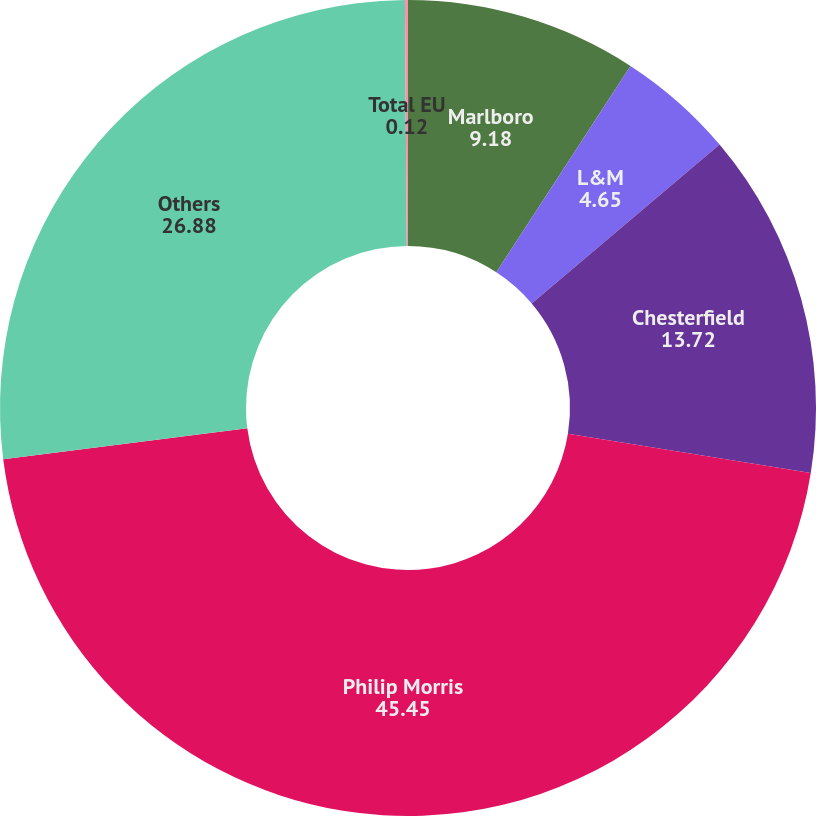<chart> <loc_0><loc_0><loc_500><loc_500><pie_chart><fcel>Marlboro<fcel>L&M<fcel>Chesterfield<fcel>Philip Morris<fcel>Others<fcel>Total EU<nl><fcel>9.18%<fcel>4.65%<fcel>13.72%<fcel>45.45%<fcel>26.88%<fcel>0.12%<nl></chart> 